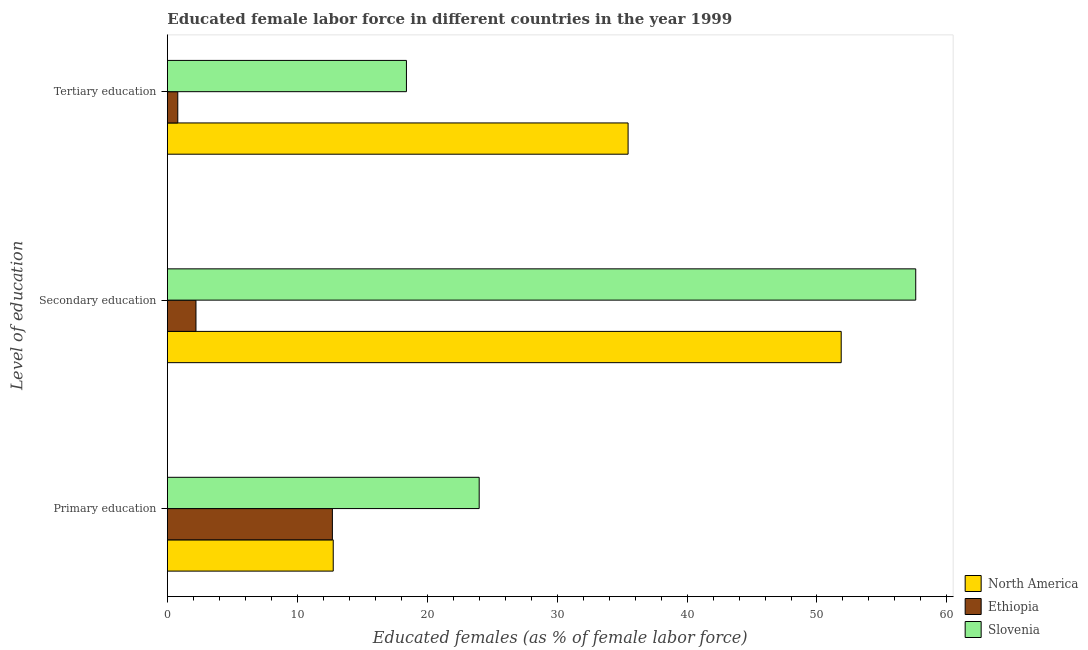How many different coloured bars are there?
Provide a short and direct response. 3. How many groups of bars are there?
Your response must be concise. 3. Are the number of bars per tick equal to the number of legend labels?
Give a very brief answer. Yes. How many bars are there on the 1st tick from the top?
Give a very brief answer. 3. What is the label of the 1st group of bars from the top?
Your answer should be very brief. Tertiary education. What is the percentage of female labor force who received primary education in North America?
Make the answer very short. 12.77. Across all countries, what is the maximum percentage of female labor force who received secondary education?
Give a very brief answer. 57.6. Across all countries, what is the minimum percentage of female labor force who received secondary education?
Your answer should be very brief. 2.2. In which country was the percentage of female labor force who received secondary education maximum?
Provide a succinct answer. Slovenia. In which country was the percentage of female labor force who received tertiary education minimum?
Provide a succinct answer. Ethiopia. What is the total percentage of female labor force who received primary education in the graph?
Your answer should be compact. 49.47. What is the difference between the percentage of female labor force who received primary education in Ethiopia and that in Slovenia?
Offer a terse response. -11.3. What is the difference between the percentage of female labor force who received tertiary education in Ethiopia and the percentage of female labor force who received secondary education in Slovenia?
Give a very brief answer. -56.8. What is the average percentage of female labor force who received secondary education per country?
Keep it short and to the point. 37.22. What is the difference between the percentage of female labor force who received primary education and percentage of female labor force who received tertiary education in Slovenia?
Keep it short and to the point. 5.6. What is the ratio of the percentage of female labor force who received primary education in Slovenia to that in North America?
Ensure brevity in your answer.  1.88. Is the percentage of female labor force who received tertiary education in Ethiopia less than that in North America?
Offer a terse response. Yes. What is the difference between the highest and the second highest percentage of female labor force who received tertiary education?
Offer a terse response. 17.06. What is the difference between the highest and the lowest percentage of female labor force who received secondary education?
Your answer should be compact. 55.4. In how many countries, is the percentage of female labor force who received secondary education greater than the average percentage of female labor force who received secondary education taken over all countries?
Offer a very short reply. 2. What does the 3rd bar from the top in Secondary education represents?
Ensure brevity in your answer.  North America. What does the 2nd bar from the bottom in Tertiary education represents?
Your answer should be very brief. Ethiopia. Is it the case that in every country, the sum of the percentage of female labor force who received primary education and percentage of female labor force who received secondary education is greater than the percentage of female labor force who received tertiary education?
Give a very brief answer. Yes. Are all the bars in the graph horizontal?
Ensure brevity in your answer.  Yes. How many countries are there in the graph?
Provide a short and direct response. 3. Are the values on the major ticks of X-axis written in scientific E-notation?
Give a very brief answer. No. Does the graph contain any zero values?
Offer a very short reply. No. Where does the legend appear in the graph?
Provide a succinct answer. Bottom right. How are the legend labels stacked?
Provide a short and direct response. Vertical. What is the title of the graph?
Offer a very short reply. Educated female labor force in different countries in the year 1999. Does "Cayman Islands" appear as one of the legend labels in the graph?
Make the answer very short. No. What is the label or title of the X-axis?
Ensure brevity in your answer.  Educated females (as % of female labor force). What is the label or title of the Y-axis?
Offer a terse response. Level of education. What is the Educated females (as % of female labor force) of North America in Primary education?
Offer a very short reply. 12.77. What is the Educated females (as % of female labor force) of Ethiopia in Primary education?
Your answer should be very brief. 12.7. What is the Educated females (as % of female labor force) in Slovenia in Primary education?
Keep it short and to the point. 24. What is the Educated females (as % of female labor force) in North America in Secondary education?
Offer a very short reply. 51.86. What is the Educated females (as % of female labor force) in Ethiopia in Secondary education?
Your response must be concise. 2.2. What is the Educated females (as % of female labor force) in Slovenia in Secondary education?
Provide a succinct answer. 57.6. What is the Educated females (as % of female labor force) of North America in Tertiary education?
Ensure brevity in your answer.  35.46. What is the Educated females (as % of female labor force) in Ethiopia in Tertiary education?
Offer a terse response. 0.8. What is the Educated females (as % of female labor force) of Slovenia in Tertiary education?
Keep it short and to the point. 18.4. Across all Level of education, what is the maximum Educated females (as % of female labor force) in North America?
Offer a terse response. 51.86. Across all Level of education, what is the maximum Educated females (as % of female labor force) of Ethiopia?
Provide a short and direct response. 12.7. Across all Level of education, what is the maximum Educated females (as % of female labor force) of Slovenia?
Keep it short and to the point. 57.6. Across all Level of education, what is the minimum Educated females (as % of female labor force) in North America?
Provide a short and direct response. 12.77. Across all Level of education, what is the minimum Educated females (as % of female labor force) in Ethiopia?
Your answer should be very brief. 0.8. Across all Level of education, what is the minimum Educated females (as % of female labor force) of Slovenia?
Provide a succinct answer. 18.4. What is the total Educated females (as % of female labor force) in North America in the graph?
Provide a short and direct response. 100.09. What is the total Educated females (as % of female labor force) in Ethiopia in the graph?
Keep it short and to the point. 15.7. What is the total Educated females (as % of female labor force) in Slovenia in the graph?
Your answer should be compact. 100. What is the difference between the Educated females (as % of female labor force) of North America in Primary education and that in Secondary education?
Your response must be concise. -39.1. What is the difference between the Educated females (as % of female labor force) of Ethiopia in Primary education and that in Secondary education?
Keep it short and to the point. 10.5. What is the difference between the Educated females (as % of female labor force) in Slovenia in Primary education and that in Secondary education?
Provide a short and direct response. -33.6. What is the difference between the Educated females (as % of female labor force) of North America in Primary education and that in Tertiary education?
Offer a very short reply. -22.69. What is the difference between the Educated females (as % of female labor force) of Ethiopia in Primary education and that in Tertiary education?
Provide a succinct answer. 11.9. What is the difference between the Educated females (as % of female labor force) in Slovenia in Primary education and that in Tertiary education?
Provide a succinct answer. 5.6. What is the difference between the Educated females (as % of female labor force) in North America in Secondary education and that in Tertiary education?
Provide a short and direct response. 16.4. What is the difference between the Educated females (as % of female labor force) of Slovenia in Secondary education and that in Tertiary education?
Your answer should be compact. 39.2. What is the difference between the Educated females (as % of female labor force) in North America in Primary education and the Educated females (as % of female labor force) in Ethiopia in Secondary education?
Offer a very short reply. 10.57. What is the difference between the Educated females (as % of female labor force) of North America in Primary education and the Educated females (as % of female labor force) of Slovenia in Secondary education?
Your answer should be compact. -44.83. What is the difference between the Educated females (as % of female labor force) in Ethiopia in Primary education and the Educated females (as % of female labor force) in Slovenia in Secondary education?
Your answer should be compact. -44.9. What is the difference between the Educated females (as % of female labor force) in North America in Primary education and the Educated females (as % of female labor force) in Ethiopia in Tertiary education?
Offer a terse response. 11.97. What is the difference between the Educated females (as % of female labor force) of North America in Primary education and the Educated females (as % of female labor force) of Slovenia in Tertiary education?
Keep it short and to the point. -5.63. What is the difference between the Educated females (as % of female labor force) in Ethiopia in Primary education and the Educated females (as % of female labor force) in Slovenia in Tertiary education?
Keep it short and to the point. -5.7. What is the difference between the Educated females (as % of female labor force) of North America in Secondary education and the Educated females (as % of female labor force) of Ethiopia in Tertiary education?
Provide a succinct answer. 51.06. What is the difference between the Educated females (as % of female labor force) of North America in Secondary education and the Educated females (as % of female labor force) of Slovenia in Tertiary education?
Ensure brevity in your answer.  33.46. What is the difference between the Educated females (as % of female labor force) in Ethiopia in Secondary education and the Educated females (as % of female labor force) in Slovenia in Tertiary education?
Your answer should be very brief. -16.2. What is the average Educated females (as % of female labor force) of North America per Level of education?
Keep it short and to the point. 33.36. What is the average Educated females (as % of female labor force) of Ethiopia per Level of education?
Give a very brief answer. 5.23. What is the average Educated females (as % of female labor force) of Slovenia per Level of education?
Ensure brevity in your answer.  33.33. What is the difference between the Educated females (as % of female labor force) of North America and Educated females (as % of female labor force) of Ethiopia in Primary education?
Ensure brevity in your answer.  0.07. What is the difference between the Educated females (as % of female labor force) in North America and Educated females (as % of female labor force) in Slovenia in Primary education?
Offer a terse response. -11.23. What is the difference between the Educated females (as % of female labor force) of Ethiopia and Educated females (as % of female labor force) of Slovenia in Primary education?
Provide a short and direct response. -11.3. What is the difference between the Educated females (as % of female labor force) in North America and Educated females (as % of female labor force) in Ethiopia in Secondary education?
Keep it short and to the point. 49.66. What is the difference between the Educated females (as % of female labor force) of North America and Educated females (as % of female labor force) of Slovenia in Secondary education?
Your answer should be very brief. -5.74. What is the difference between the Educated females (as % of female labor force) in Ethiopia and Educated females (as % of female labor force) in Slovenia in Secondary education?
Your response must be concise. -55.4. What is the difference between the Educated females (as % of female labor force) in North America and Educated females (as % of female labor force) in Ethiopia in Tertiary education?
Your answer should be compact. 34.66. What is the difference between the Educated females (as % of female labor force) in North America and Educated females (as % of female labor force) in Slovenia in Tertiary education?
Keep it short and to the point. 17.06. What is the difference between the Educated females (as % of female labor force) in Ethiopia and Educated females (as % of female labor force) in Slovenia in Tertiary education?
Offer a terse response. -17.6. What is the ratio of the Educated females (as % of female labor force) in North America in Primary education to that in Secondary education?
Provide a short and direct response. 0.25. What is the ratio of the Educated females (as % of female labor force) in Ethiopia in Primary education to that in Secondary education?
Provide a succinct answer. 5.77. What is the ratio of the Educated females (as % of female labor force) of Slovenia in Primary education to that in Secondary education?
Provide a short and direct response. 0.42. What is the ratio of the Educated females (as % of female labor force) of North America in Primary education to that in Tertiary education?
Provide a succinct answer. 0.36. What is the ratio of the Educated females (as % of female labor force) in Ethiopia in Primary education to that in Tertiary education?
Your answer should be compact. 15.88. What is the ratio of the Educated females (as % of female labor force) in Slovenia in Primary education to that in Tertiary education?
Your answer should be very brief. 1.3. What is the ratio of the Educated females (as % of female labor force) of North America in Secondary education to that in Tertiary education?
Your response must be concise. 1.46. What is the ratio of the Educated females (as % of female labor force) of Ethiopia in Secondary education to that in Tertiary education?
Ensure brevity in your answer.  2.75. What is the ratio of the Educated females (as % of female labor force) of Slovenia in Secondary education to that in Tertiary education?
Offer a terse response. 3.13. What is the difference between the highest and the second highest Educated females (as % of female labor force) in North America?
Your response must be concise. 16.4. What is the difference between the highest and the second highest Educated females (as % of female labor force) of Ethiopia?
Offer a terse response. 10.5. What is the difference between the highest and the second highest Educated females (as % of female labor force) in Slovenia?
Make the answer very short. 33.6. What is the difference between the highest and the lowest Educated females (as % of female labor force) in North America?
Your response must be concise. 39.1. What is the difference between the highest and the lowest Educated females (as % of female labor force) of Ethiopia?
Keep it short and to the point. 11.9. What is the difference between the highest and the lowest Educated females (as % of female labor force) of Slovenia?
Your answer should be compact. 39.2. 